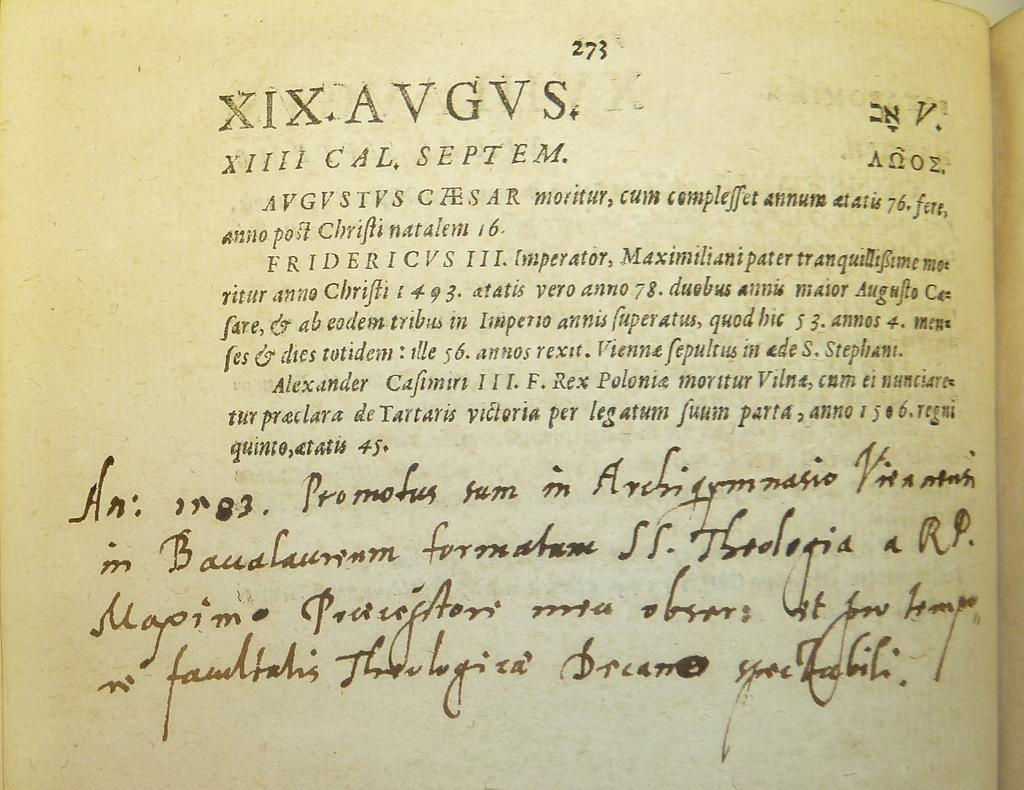<image>
Render a clear and concise summary of the photo. an old book with print and handwriting refers to Alexander Calfimiri 